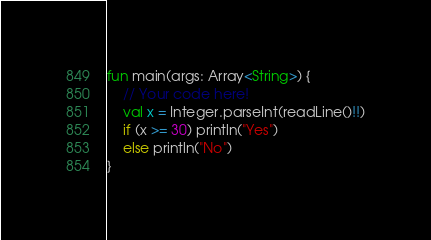Convert code to text. <code><loc_0><loc_0><loc_500><loc_500><_Kotlin_>fun main(args: Array<String>) {
    // Your code here!
    val x = Integer.parseInt(readLine()!!)
    if (x >= 30) println("Yes")
    else println("No")
}</code> 